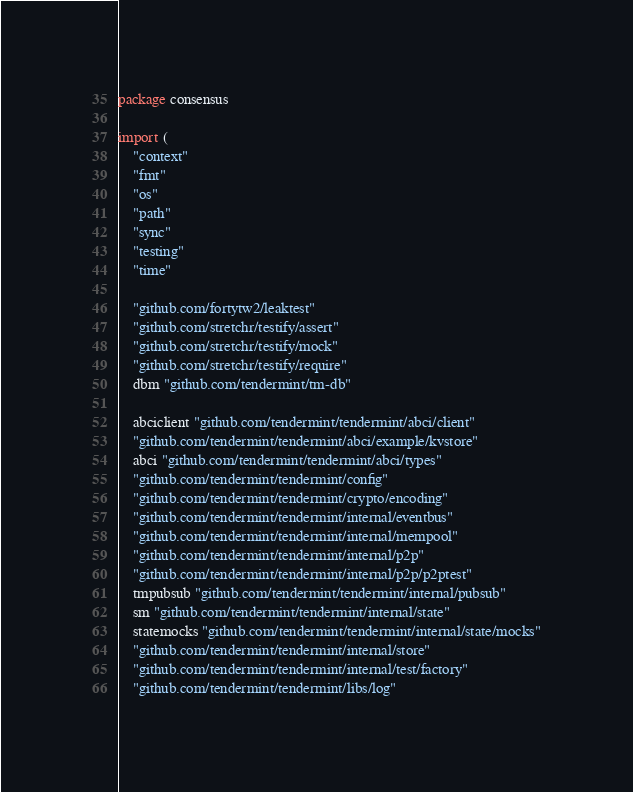Convert code to text. <code><loc_0><loc_0><loc_500><loc_500><_Go_>package consensus

import (
	"context"
	"fmt"
	"os"
	"path"
	"sync"
	"testing"
	"time"

	"github.com/fortytw2/leaktest"
	"github.com/stretchr/testify/assert"
	"github.com/stretchr/testify/mock"
	"github.com/stretchr/testify/require"
	dbm "github.com/tendermint/tm-db"

	abciclient "github.com/tendermint/tendermint/abci/client"
	"github.com/tendermint/tendermint/abci/example/kvstore"
	abci "github.com/tendermint/tendermint/abci/types"
	"github.com/tendermint/tendermint/config"
	"github.com/tendermint/tendermint/crypto/encoding"
	"github.com/tendermint/tendermint/internal/eventbus"
	"github.com/tendermint/tendermint/internal/mempool"
	"github.com/tendermint/tendermint/internal/p2p"
	"github.com/tendermint/tendermint/internal/p2p/p2ptest"
	tmpubsub "github.com/tendermint/tendermint/internal/pubsub"
	sm "github.com/tendermint/tendermint/internal/state"
	statemocks "github.com/tendermint/tendermint/internal/state/mocks"
	"github.com/tendermint/tendermint/internal/store"
	"github.com/tendermint/tendermint/internal/test/factory"
	"github.com/tendermint/tendermint/libs/log"</code> 